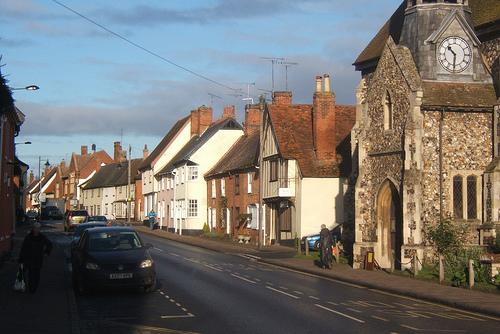Is this in America?
Keep it brief. No. Is this a big city?
Write a very short answer. No. Is there a roof on this car?
Concise answer only. Yes. What time does the clock show?
Quick response, please. 10:30. 